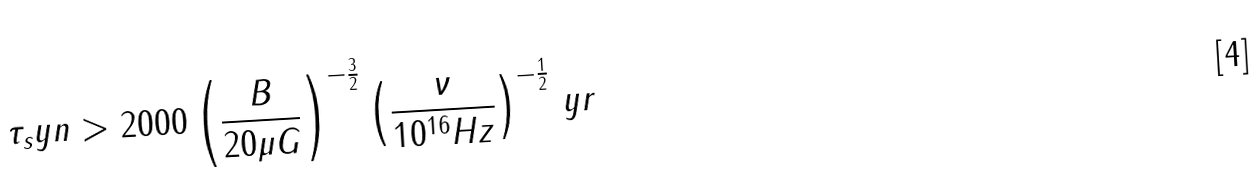<formula> <loc_0><loc_0><loc_500><loc_500>\tau _ { s } y n > 2 0 0 0 \left ( \frac { B } { 2 0 \mu G } \right ) ^ { - \frac { 3 } { 2 } } \left ( \frac { \nu } { 1 0 ^ { 1 6 } H z } \right ) ^ { - \frac { 1 } { 2 } } \, y r</formula> 